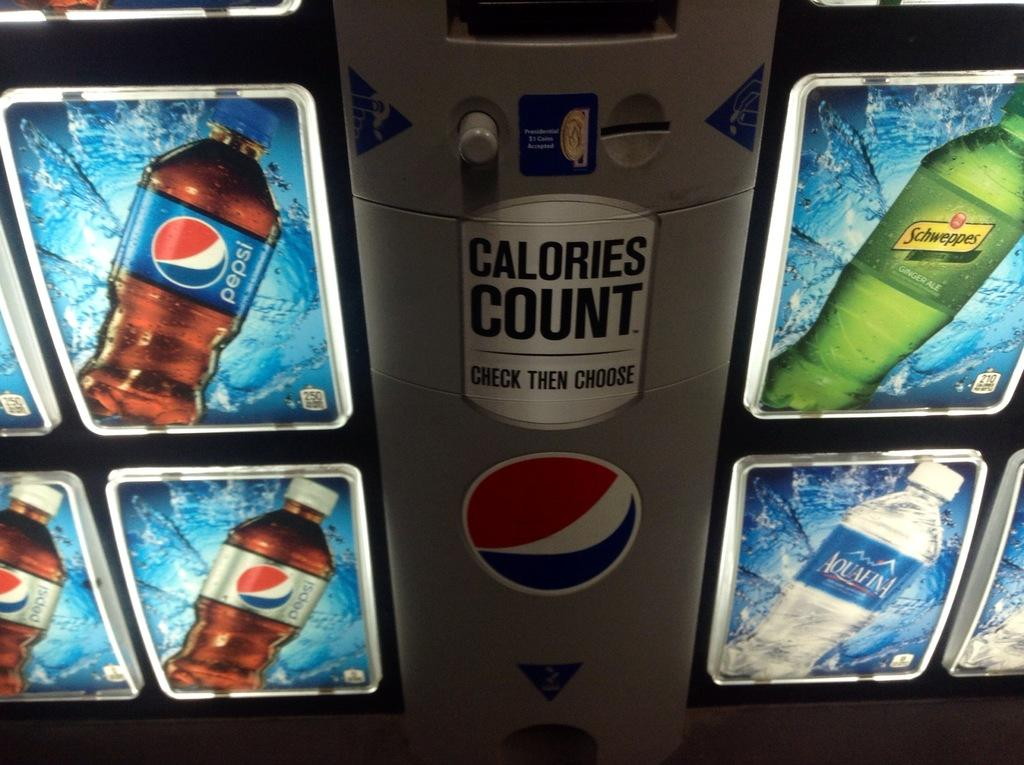<image>
Offer a succinct explanation of the picture presented. A soda machine with Pepsi, diet Pepsi and Aquafina 